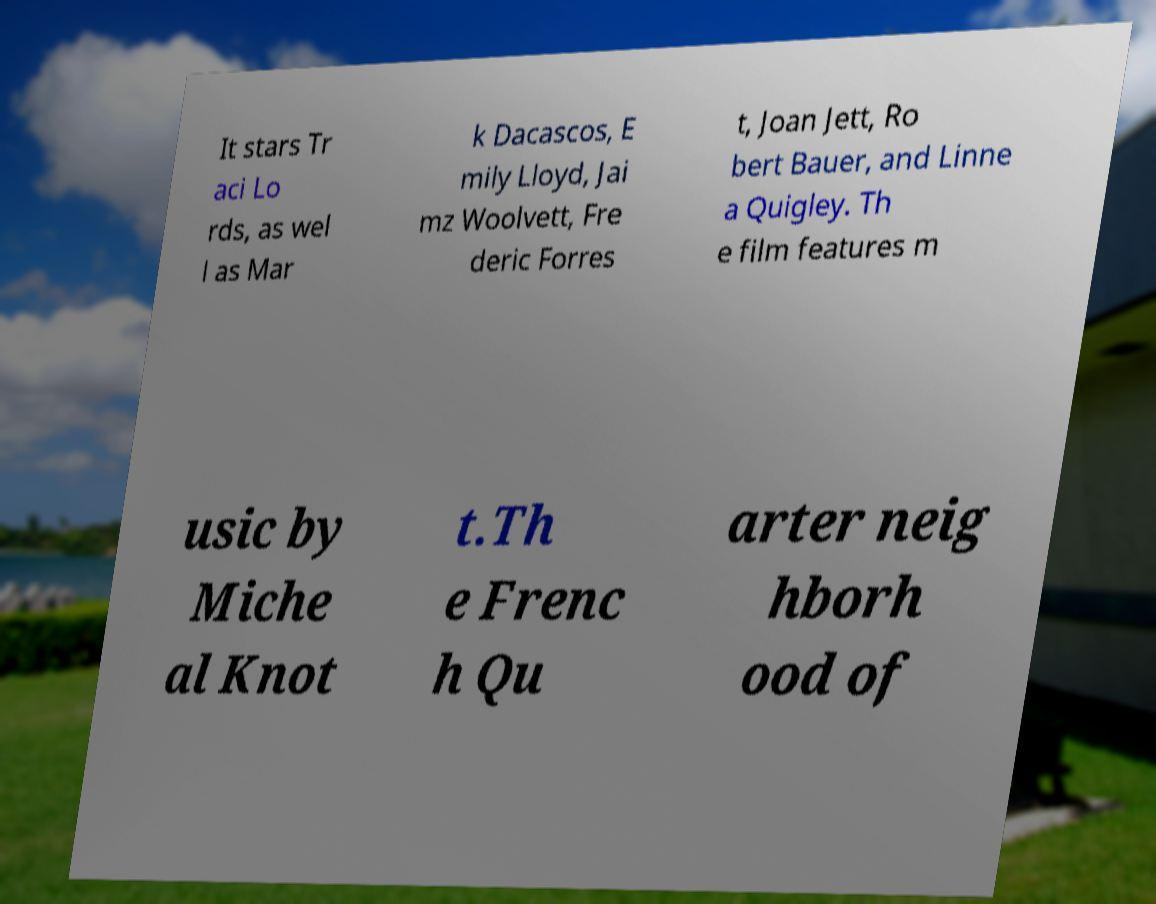Please read and relay the text visible in this image. What does it say? It stars Tr aci Lo rds, as wel l as Mar k Dacascos, E mily Lloyd, Jai mz Woolvett, Fre deric Forres t, Joan Jett, Ro bert Bauer, and Linne a Quigley. Th e film features m usic by Miche al Knot t.Th e Frenc h Qu arter neig hborh ood of 